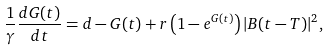<formula> <loc_0><loc_0><loc_500><loc_500>\frac { 1 } { \gamma } \frac { d G ( t ) } { d t } = d - G ( t ) + r \left ( 1 - e ^ { G ( t ) } \right ) | B ( t - T ) | ^ { 2 } ,</formula> 